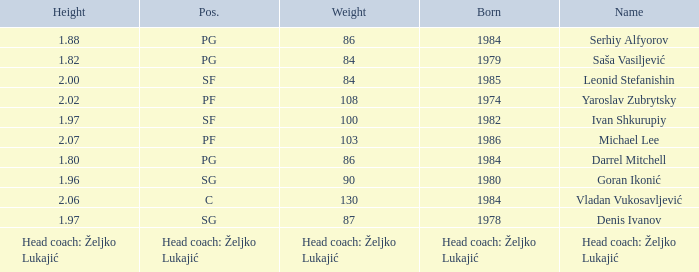What is the position of the player born in 1984 with a height of 1.80m? PG. 